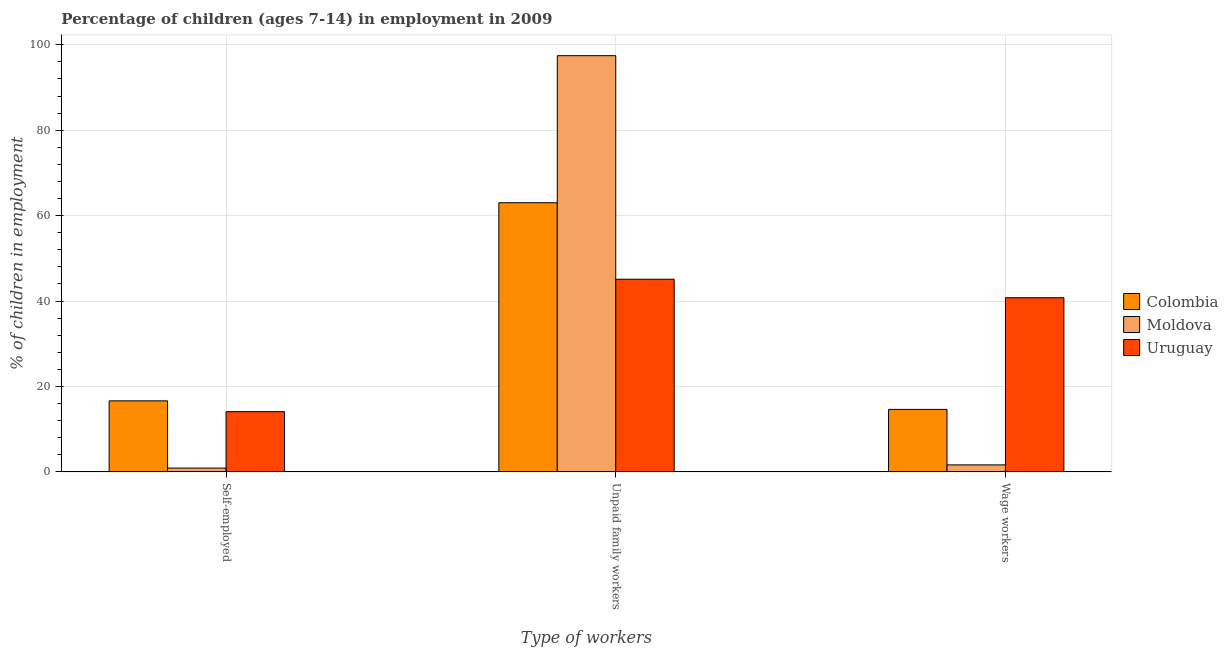How many different coloured bars are there?
Give a very brief answer. 3. Are the number of bars per tick equal to the number of legend labels?
Make the answer very short. Yes. How many bars are there on the 1st tick from the left?
Make the answer very short. 3. How many bars are there on the 2nd tick from the right?
Ensure brevity in your answer.  3. What is the label of the 2nd group of bars from the left?
Give a very brief answer. Unpaid family workers. What is the percentage of children employed as wage workers in Moldova?
Offer a terse response. 1.65. Across all countries, what is the maximum percentage of children employed as unpaid family workers?
Give a very brief answer. 97.44. Across all countries, what is the minimum percentage of children employed as wage workers?
Offer a very short reply. 1.65. In which country was the percentage of self employed children maximum?
Your answer should be compact. Colombia. In which country was the percentage of self employed children minimum?
Your answer should be compact. Moldova. What is the total percentage of children employed as unpaid family workers in the graph?
Provide a short and direct response. 205.57. What is the difference between the percentage of children employed as unpaid family workers in Moldova and that in Uruguay?
Offer a terse response. 52.33. What is the difference between the percentage of self employed children in Colombia and the percentage of children employed as unpaid family workers in Uruguay?
Make the answer very short. -28.47. What is the average percentage of self employed children per country?
Offer a very short reply. 10.55. What is the difference between the percentage of children employed as wage workers and percentage of children employed as unpaid family workers in Uruguay?
Offer a terse response. -4.33. What is the ratio of the percentage of self employed children in Uruguay to that in Moldova?
Ensure brevity in your answer.  15.51. Is the percentage of children employed as unpaid family workers in Uruguay less than that in Colombia?
Your answer should be very brief. Yes. Is the difference between the percentage of children employed as wage workers in Uruguay and Moldova greater than the difference between the percentage of children employed as unpaid family workers in Uruguay and Moldova?
Offer a terse response. Yes. What is the difference between the highest and the second highest percentage of children employed as wage workers?
Ensure brevity in your answer.  26.14. What is the difference between the highest and the lowest percentage of self employed children?
Your answer should be very brief. 15.73. What does the 3rd bar from the left in Wage workers represents?
Keep it short and to the point. Uruguay. What does the 2nd bar from the right in Unpaid family workers represents?
Make the answer very short. Moldova. Is it the case that in every country, the sum of the percentage of self employed children and percentage of children employed as unpaid family workers is greater than the percentage of children employed as wage workers?
Give a very brief answer. Yes. Does the graph contain any zero values?
Offer a terse response. No. Does the graph contain grids?
Your answer should be compact. Yes. Where does the legend appear in the graph?
Offer a terse response. Center right. How are the legend labels stacked?
Keep it short and to the point. Vertical. What is the title of the graph?
Keep it short and to the point. Percentage of children (ages 7-14) in employment in 2009. Does "Ireland" appear as one of the legend labels in the graph?
Offer a very short reply. No. What is the label or title of the X-axis?
Give a very brief answer. Type of workers. What is the label or title of the Y-axis?
Keep it short and to the point. % of children in employment. What is the % of children in employment of Colombia in Self-employed?
Provide a short and direct response. 16.64. What is the % of children in employment of Moldova in Self-employed?
Ensure brevity in your answer.  0.91. What is the % of children in employment in Uruguay in Self-employed?
Make the answer very short. 14.11. What is the % of children in employment in Colombia in Unpaid family workers?
Your answer should be compact. 63.02. What is the % of children in employment in Moldova in Unpaid family workers?
Give a very brief answer. 97.44. What is the % of children in employment of Uruguay in Unpaid family workers?
Ensure brevity in your answer.  45.11. What is the % of children in employment of Colombia in Wage workers?
Ensure brevity in your answer.  14.64. What is the % of children in employment in Moldova in Wage workers?
Your response must be concise. 1.65. What is the % of children in employment of Uruguay in Wage workers?
Your answer should be very brief. 40.78. Across all Type of workers, what is the maximum % of children in employment of Colombia?
Ensure brevity in your answer.  63.02. Across all Type of workers, what is the maximum % of children in employment of Moldova?
Keep it short and to the point. 97.44. Across all Type of workers, what is the maximum % of children in employment of Uruguay?
Keep it short and to the point. 45.11. Across all Type of workers, what is the minimum % of children in employment of Colombia?
Make the answer very short. 14.64. Across all Type of workers, what is the minimum % of children in employment of Moldova?
Make the answer very short. 0.91. Across all Type of workers, what is the minimum % of children in employment of Uruguay?
Provide a succinct answer. 14.11. What is the total % of children in employment of Colombia in the graph?
Your answer should be very brief. 94.3. What is the total % of children in employment in Uruguay in the graph?
Keep it short and to the point. 100. What is the difference between the % of children in employment in Colombia in Self-employed and that in Unpaid family workers?
Your answer should be compact. -46.38. What is the difference between the % of children in employment in Moldova in Self-employed and that in Unpaid family workers?
Your answer should be very brief. -96.53. What is the difference between the % of children in employment in Uruguay in Self-employed and that in Unpaid family workers?
Offer a terse response. -31. What is the difference between the % of children in employment of Moldova in Self-employed and that in Wage workers?
Your response must be concise. -0.74. What is the difference between the % of children in employment of Uruguay in Self-employed and that in Wage workers?
Offer a very short reply. -26.67. What is the difference between the % of children in employment in Colombia in Unpaid family workers and that in Wage workers?
Make the answer very short. 48.38. What is the difference between the % of children in employment of Moldova in Unpaid family workers and that in Wage workers?
Offer a terse response. 95.79. What is the difference between the % of children in employment of Uruguay in Unpaid family workers and that in Wage workers?
Provide a short and direct response. 4.33. What is the difference between the % of children in employment of Colombia in Self-employed and the % of children in employment of Moldova in Unpaid family workers?
Your response must be concise. -80.8. What is the difference between the % of children in employment of Colombia in Self-employed and the % of children in employment of Uruguay in Unpaid family workers?
Provide a succinct answer. -28.47. What is the difference between the % of children in employment of Moldova in Self-employed and the % of children in employment of Uruguay in Unpaid family workers?
Offer a terse response. -44.2. What is the difference between the % of children in employment of Colombia in Self-employed and the % of children in employment of Moldova in Wage workers?
Your response must be concise. 14.99. What is the difference between the % of children in employment of Colombia in Self-employed and the % of children in employment of Uruguay in Wage workers?
Ensure brevity in your answer.  -24.14. What is the difference between the % of children in employment in Moldova in Self-employed and the % of children in employment in Uruguay in Wage workers?
Offer a very short reply. -39.87. What is the difference between the % of children in employment of Colombia in Unpaid family workers and the % of children in employment of Moldova in Wage workers?
Ensure brevity in your answer.  61.37. What is the difference between the % of children in employment of Colombia in Unpaid family workers and the % of children in employment of Uruguay in Wage workers?
Your answer should be very brief. 22.24. What is the difference between the % of children in employment of Moldova in Unpaid family workers and the % of children in employment of Uruguay in Wage workers?
Your response must be concise. 56.66. What is the average % of children in employment of Colombia per Type of workers?
Provide a short and direct response. 31.43. What is the average % of children in employment in Moldova per Type of workers?
Give a very brief answer. 33.33. What is the average % of children in employment of Uruguay per Type of workers?
Provide a succinct answer. 33.33. What is the difference between the % of children in employment of Colombia and % of children in employment of Moldova in Self-employed?
Your response must be concise. 15.73. What is the difference between the % of children in employment in Colombia and % of children in employment in Uruguay in Self-employed?
Your answer should be compact. 2.53. What is the difference between the % of children in employment of Colombia and % of children in employment of Moldova in Unpaid family workers?
Your response must be concise. -34.42. What is the difference between the % of children in employment in Colombia and % of children in employment in Uruguay in Unpaid family workers?
Keep it short and to the point. 17.91. What is the difference between the % of children in employment of Moldova and % of children in employment of Uruguay in Unpaid family workers?
Offer a terse response. 52.33. What is the difference between the % of children in employment in Colombia and % of children in employment in Moldova in Wage workers?
Offer a terse response. 12.99. What is the difference between the % of children in employment in Colombia and % of children in employment in Uruguay in Wage workers?
Ensure brevity in your answer.  -26.14. What is the difference between the % of children in employment of Moldova and % of children in employment of Uruguay in Wage workers?
Offer a terse response. -39.13. What is the ratio of the % of children in employment in Colombia in Self-employed to that in Unpaid family workers?
Your answer should be very brief. 0.26. What is the ratio of the % of children in employment in Moldova in Self-employed to that in Unpaid family workers?
Provide a succinct answer. 0.01. What is the ratio of the % of children in employment of Uruguay in Self-employed to that in Unpaid family workers?
Provide a succinct answer. 0.31. What is the ratio of the % of children in employment of Colombia in Self-employed to that in Wage workers?
Offer a very short reply. 1.14. What is the ratio of the % of children in employment of Moldova in Self-employed to that in Wage workers?
Provide a succinct answer. 0.55. What is the ratio of the % of children in employment in Uruguay in Self-employed to that in Wage workers?
Provide a succinct answer. 0.35. What is the ratio of the % of children in employment in Colombia in Unpaid family workers to that in Wage workers?
Give a very brief answer. 4.3. What is the ratio of the % of children in employment of Moldova in Unpaid family workers to that in Wage workers?
Your answer should be compact. 59.05. What is the ratio of the % of children in employment in Uruguay in Unpaid family workers to that in Wage workers?
Your response must be concise. 1.11. What is the difference between the highest and the second highest % of children in employment of Colombia?
Make the answer very short. 46.38. What is the difference between the highest and the second highest % of children in employment in Moldova?
Offer a very short reply. 95.79. What is the difference between the highest and the second highest % of children in employment of Uruguay?
Ensure brevity in your answer.  4.33. What is the difference between the highest and the lowest % of children in employment in Colombia?
Offer a very short reply. 48.38. What is the difference between the highest and the lowest % of children in employment of Moldova?
Your answer should be very brief. 96.53. What is the difference between the highest and the lowest % of children in employment in Uruguay?
Offer a very short reply. 31. 